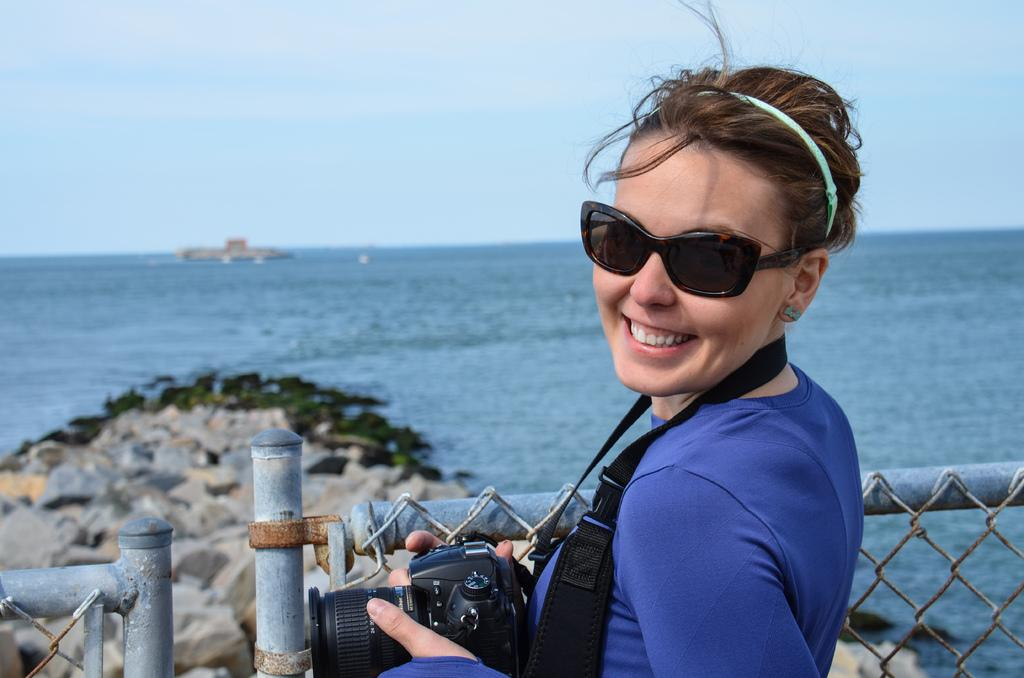Who is the main subject in the picture? There is a woman in the picture. What is the woman wearing on her face? The woman is wearing goggles. What is the woman wearing on her head? The woman is wearing a headband. What expression does the woman have? The woman is smiling. What is the woman holding in her hands? The woman is holding a camera. Where is the woman standing in the picture? The woman is standing at a fence. What can be seen in the background of the picture? Water, rocks, and the sky are visible in the background. What is the chance of the woman's friend joining her in the picture? There is no mention of a friend in the image, so it is impossible to determine the chance of them joining the woman. 